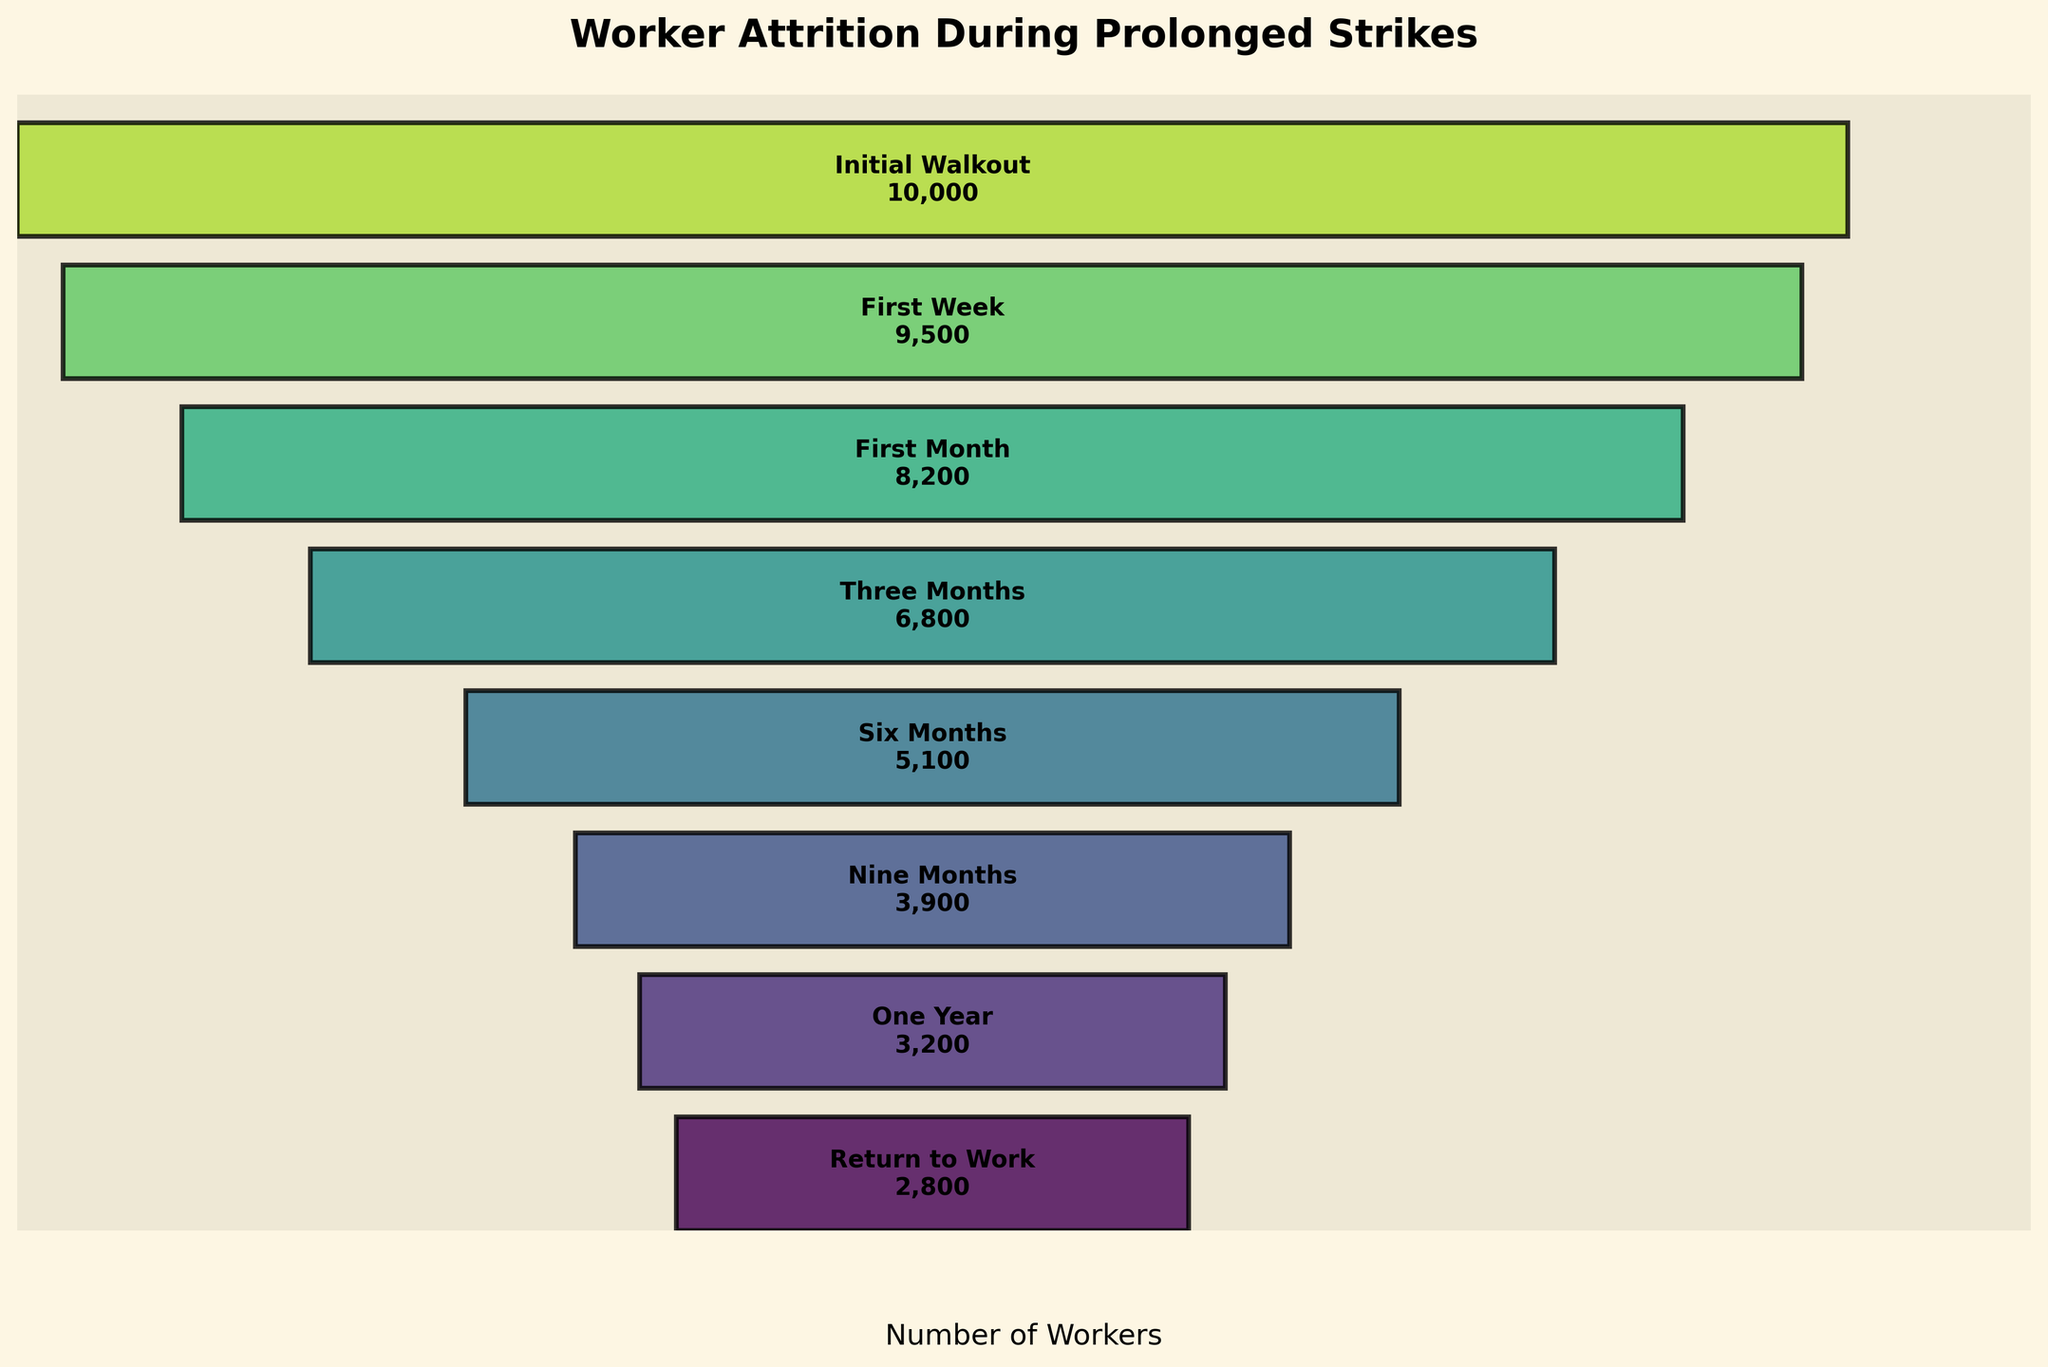What is the title of the figure? The title is typically at the top of the figure and provides a summary of what the figure represents. In this case, it is written in bold and reads "Worker Attrition During Prolonged Strikes".
Answer: Worker Attrition During Prolonged Strikes How many workers were involved in the initial walkout? This information is at the top of the funnel chart in the largest section labeled "Initial Walkout". The number written there is 10,000.
Answer: 10,000 Which stage shows the smallest number of workers? By observing the funnel chart, the smallest section would be at the very bottom of the funnel. This section is labeled "Return to Work" with the number 2,800.
Answer: Return to Work How many stages show a loss of workers during the strike? To determine this, count the number of distinct sections from top to bottom in the funnel chart. There are eight stages listed: Initial Walkout, First Week, First Month, Three Months, Six Months, Nine Months, One Year, and Return to Work. Thus, seven stages show a loss as Return to Work only shows a return count.
Answer: 7 stages Compare the number of workers in the "First Month" and "Three Months" stages. How many workers were lost during this period? Find the numbers for both stages from the figure: "First Month" has 8,200 workers, and "Three Months" has 6,800 workers. Subtract the latter from the former to find the loss: 8,200 - 6,800 = 1,400.
Answer: 1,400 What is the percentage decrease in the number of workers from the "Six Months" to the "Nine Months" stage? Find the numbers from the figure: "Six Months" has 5,100 workers, and "Nine Months" has 3,900 workers. Calculate the percentage decrease by (5,100 - 3,900) / 5,100 * 100 = 23.53%.
Answer: 23.53% What is the average number of workers across all stages shown in the figure? Sum up the workers in all the stages: 10,000 + 9,500 + 8,200 + 6,800 + 5,100 + 3,900 + 3,200 + 2,800 = 49,500. There are 8 stages, so the average is 49,500 / 8 = 6,187.5.
Answer: 6,187.5 Which stage experienced the highest relative decline in worker numbers compared to the previous stage? Calculate the relative declines for each stage pair by finding the ratio of loss to the previous stage's numbers:
- First Week to Initial Walkout: (10,000 - 9,500) / 10,000 = 5%
- First Month to First Week: (9,500 - 8,200) / 9,500 = 13.68%
- Three Months to First Month: (8,200 - 6,800) / 8,200 = 17.07%
- Six Months to Three Months: (6,800 - 5,100) / 6,800 = 25%
- Nine Months to Six Months: (5,100 - 3,900) / 5,100 = 23.53%
- One Year to Nine Months: (3,900 - 3,200) / 3,900 = 17.95%
- Return to Work to One Year: (3,200 - 2,800) / 3,200 = 12.5%
The highest relative decline is from Six Months to Three Months.
Answer: Six Months to Three Months 